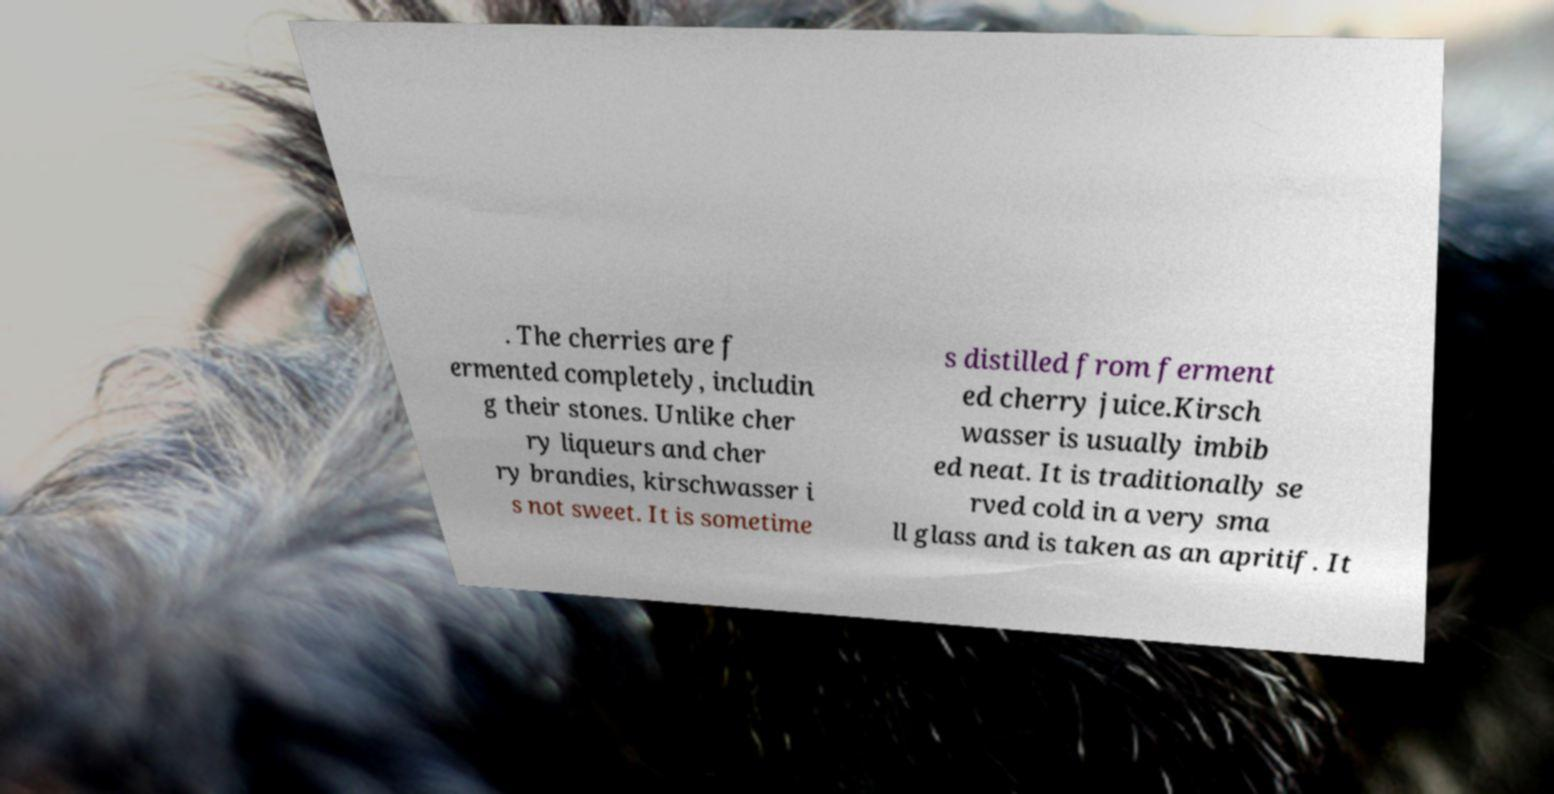Can you accurately transcribe the text from the provided image for me? . The cherries are f ermented completely, includin g their stones. Unlike cher ry liqueurs and cher ry brandies, kirschwasser i s not sweet. It is sometime s distilled from ferment ed cherry juice.Kirsch wasser is usually imbib ed neat. It is traditionally se rved cold in a very sma ll glass and is taken as an apritif. It 